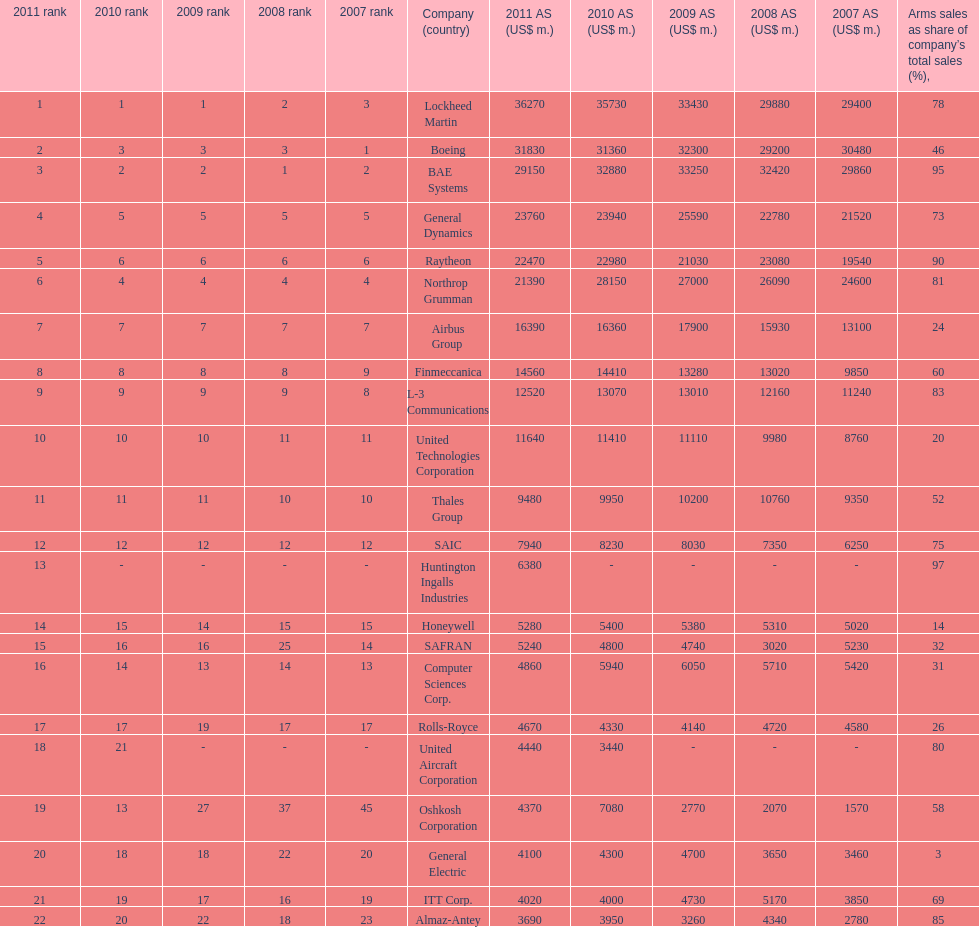How many companies are under the united states? 14. 